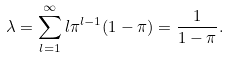Convert formula to latex. <formula><loc_0><loc_0><loc_500><loc_500>\lambda = \sum _ { l = 1 } ^ { \infty } l \pi ^ { l - 1 } ( 1 - \pi ) = \frac { 1 } { 1 - \pi } .</formula> 